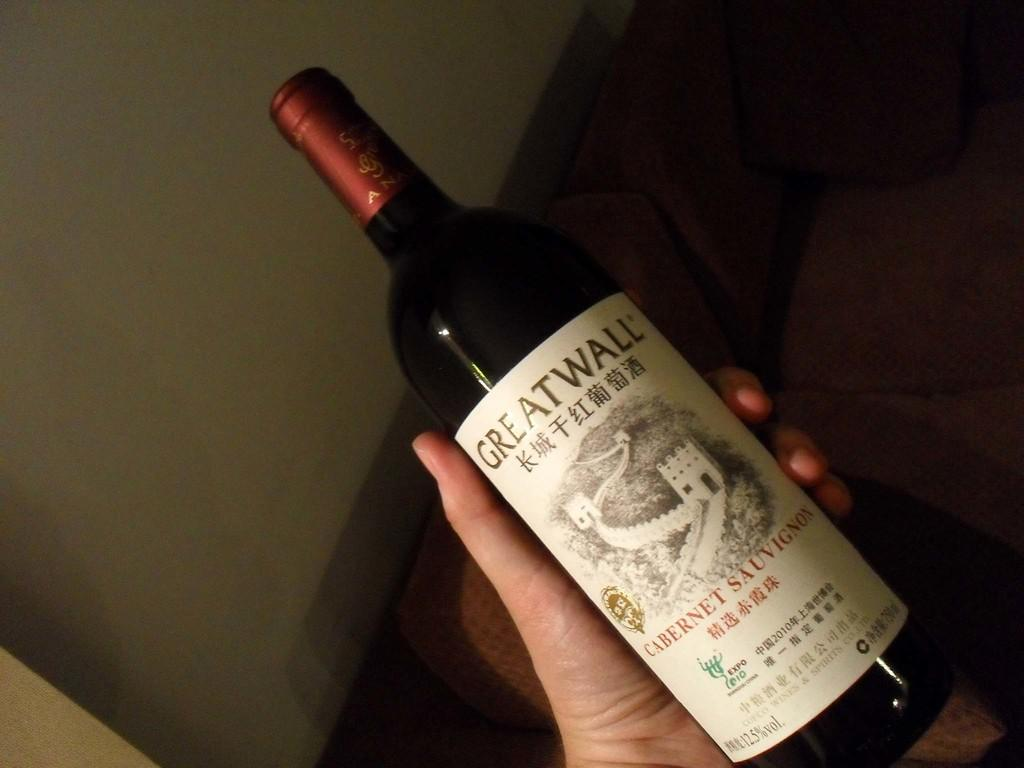Provide a one-sentence caption for the provided image. The bottle of wine says GREATWALL and is full. 